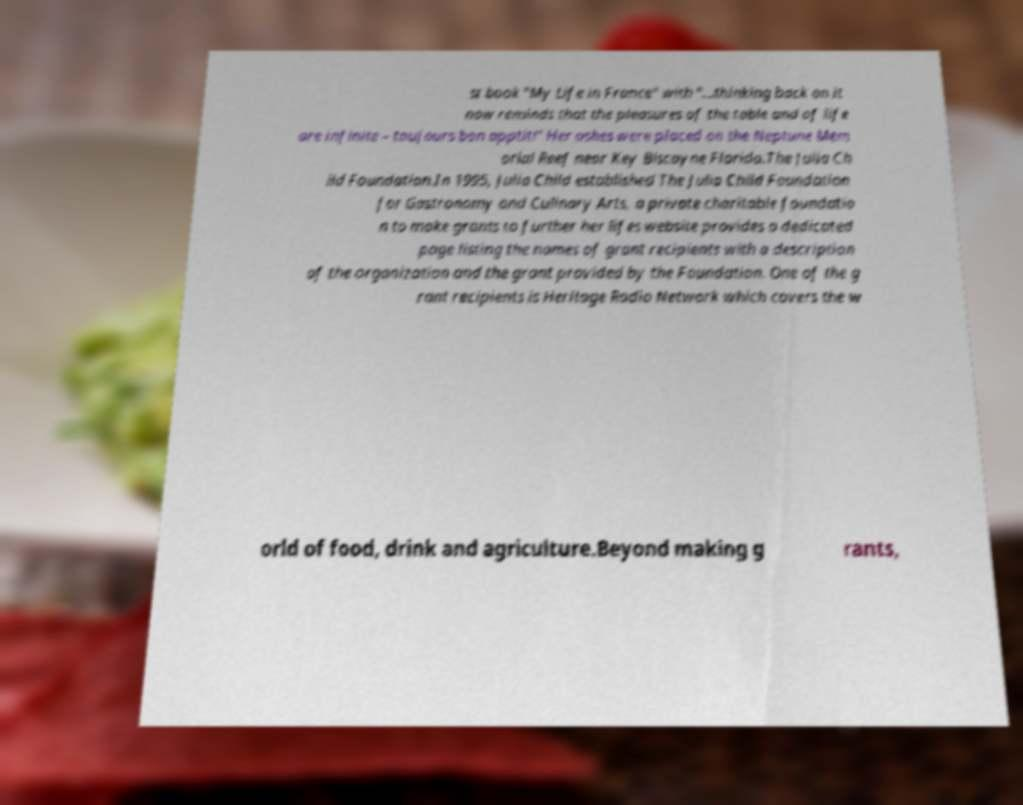Please identify and transcribe the text found in this image. st book "My Life in France" with "...thinking back on it now reminds that the pleasures of the table and of life are infinite – toujours bon apptit!" Her ashes were placed on the Neptune Mem orial Reef near Key Biscayne Florida.The Julia Ch ild Foundation.In 1995, Julia Child established The Julia Child Foundation for Gastronomy and Culinary Arts, a private charitable foundatio n to make grants to further her lifes website provides a dedicated page listing the names of grant recipients with a description of the organization and the grant provided by the Foundation. One of the g rant recipients is Heritage Radio Network which covers the w orld of food, drink and agriculture.Beyond making g rants, 